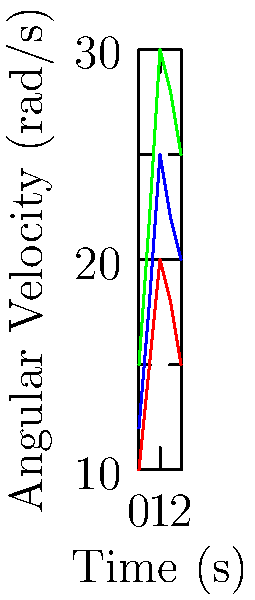The graph shows the angular velocity of finger joints while playing different musical instruments over time. Calculate the average angular acceleration of the finger joints for the violin between $t=0.5s$ and $t=1.5s$. To calculate the average angular acceleration, we need to follow these steps:

1. Identify the angular velocities at $t=0.5s$ and $t=1.5s$ for the violin:
   At $t=0.5s$, $\omega_1 = 22 \text{ rad/s}$
   At $t=1.5s$, $\omega_2 = 28 \text{ rad/s}$

2. Calculate the change in angular velocity:
   $\Delta \omega = \omega_2 - \omega_1 = 28 - 22 = 6 \text{ rad/s}$

3. Calculate the time interval:
   $\Delta t = 1.5s - 0.5s = 1s$

4. Use the formula for average angular acceleration:
   $\alpha_{avg} = \frac{\Delta \omega}{\Delta t}$

5. Substitute the values:
   $\alpha_{avg} = \frac{6 \text{ rad/s}}{1s} = 6 \text{ rad/s}^2$

Therefore, the average angular acceleration of the finger joints for the violin between $t=0.5s$ and $t=1.5s$ is $6 \text{ rad/s}^2$.
Answer: $6 \text{ rad/s}^2$ 